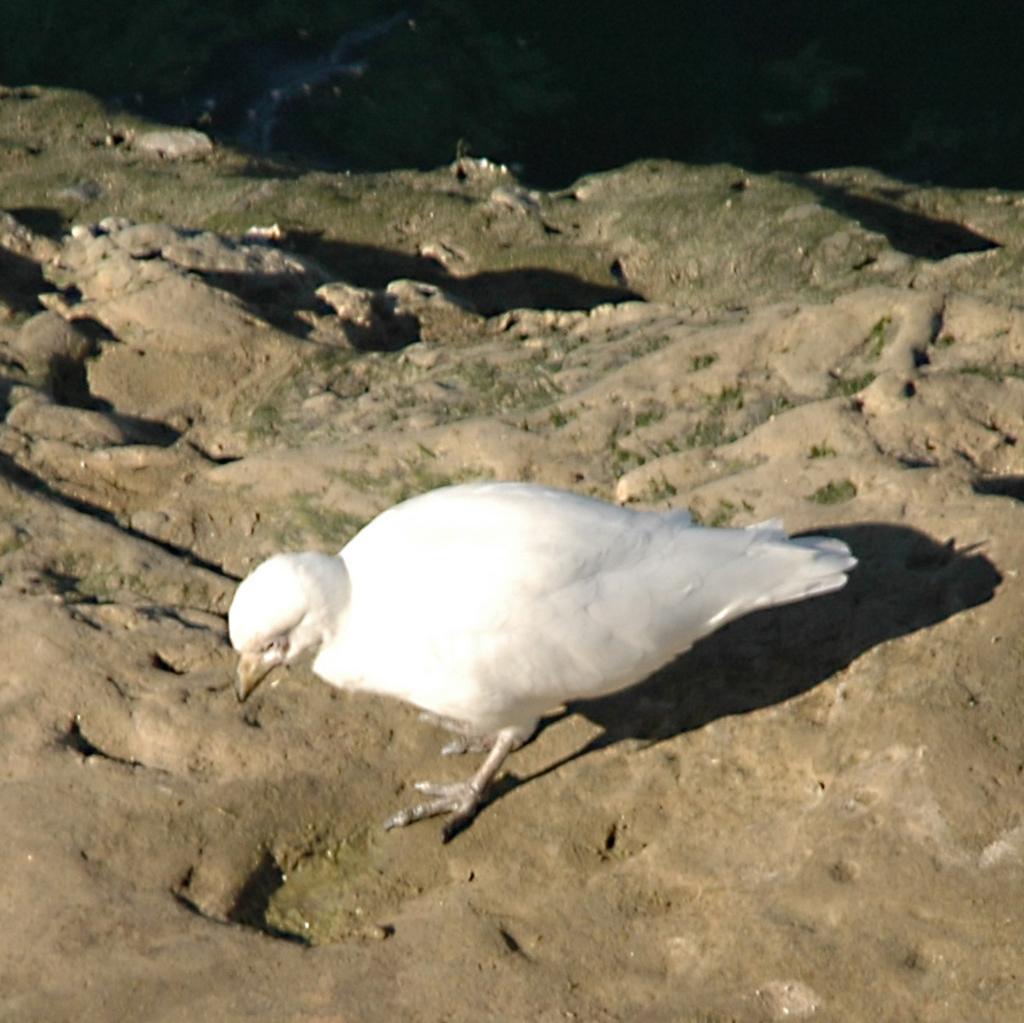How would you summarize this image in a sentence or two? In this image I can see a white colour bird in the front. I can also see shadows. 